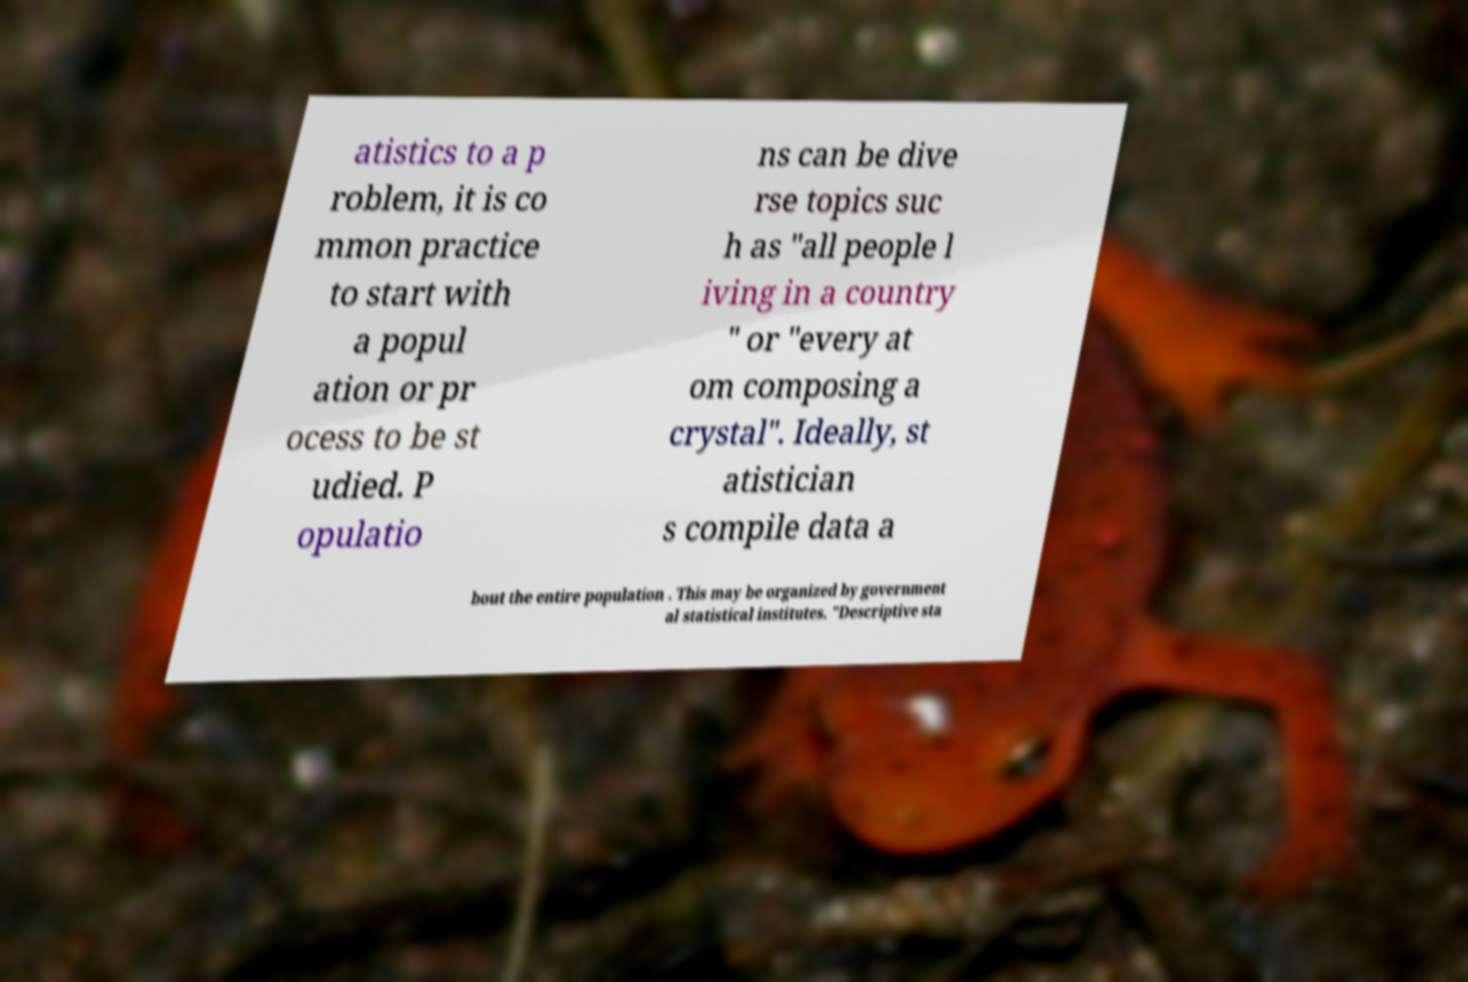Please identify and transcribe the text found in this image. atistics to a p roblem, it is co mmon practice to start with a popul ation or pr ocess to be st udied. P opulatio ns can be dive rse topics suc h as "all people l iving in a country " or "every at om composing a crystal". Ideally, st atistician s compile data a bout the entire population . This may be organized by government al statistical institutes. "Descriptive sta 